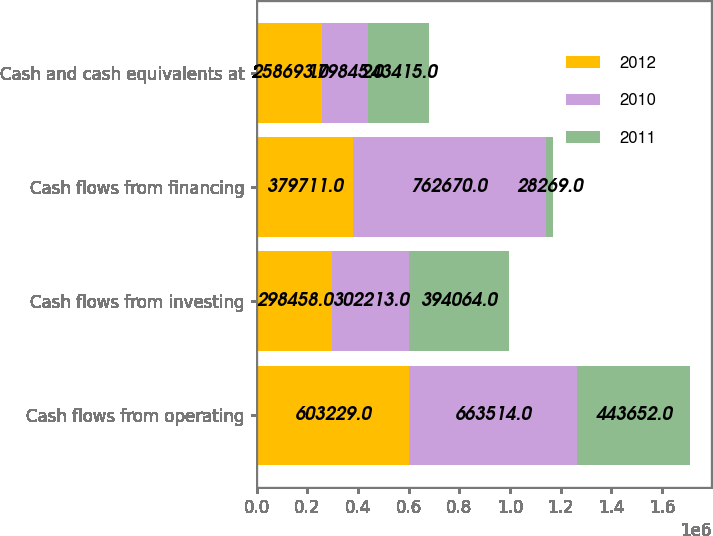Convert chart to OTSL. <chart><loc_0><loc_0><loc_500><loc_500><stacked_bar_chart><ecel><fcel>Cash flows from operating<fcel>Cash flows from investing<fcel>Cash flows from financing<fcel>Cash and cash equivalents at<nl><fcel>2012<fcel>603229<fcel>298458<fcel>379711<fcel>258693<nl><fcel>2010<fcel>663514<fcel>302213<fcel>762670<fcel>179845<nl><fcel>2011<fcel>443652<fcel>394064<fcel>28269<fcel>243415<nl></chart> 